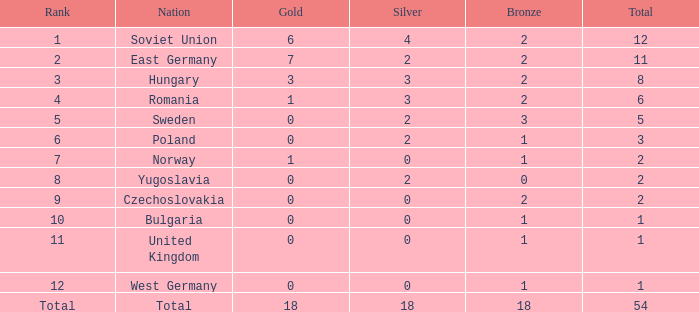What's the total of rank number 6 with more than 2 silver? None. 